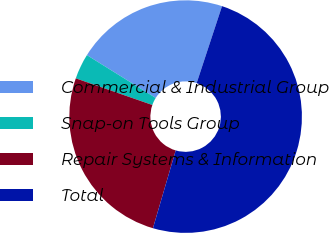Convert chart to OTSL. <chart><loc_0><loc_0><loc_500><loc_500><pie_chart><fcel>Commercial & Industrial Group<fcel>Snap-on Tools Group<fcel>Repair Systems & Information<fcel>Total<nl><fcel>21.2%<fcel>3.53%<fcel>25.8%<fcel>49.47%<nl></chart> 